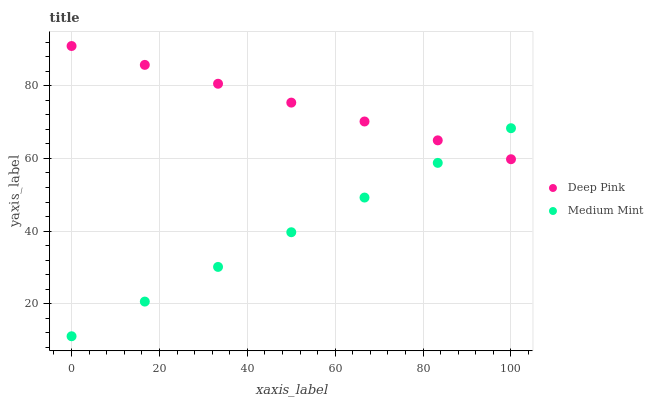Does Medium Mint have the minimum area under the curve?
Answer yes or no. Yes. Does Deep Pink have the maximum area under the curve?
Answer yes or no. Yes. Does Deep Pink have the minimum area under the curve?
Answer yes or no. No. Is Medium Mint the smoothest?
Answer yes or no. Yes. Is Deep Pink the roughest?
Answer yes or no. Yes. Is Deep Pink the smoothest?
Answer yes or no. No. Does Medium Mint have the lowest value?
Answer yes or no. Yes. Does Deep Pink have the lowest value?
Answer yes or no. No. Does Deep Pink have the highest value?
Answer yes or no. Yes. Does Medium Mint intersect Deep Pink?
Answer yes or no. Yes. Is Medium Mint less than Deep Pink?
Answer yes or no. No. Is Medium Mint greater than Deep Pink?
Answer yes or no. No. 